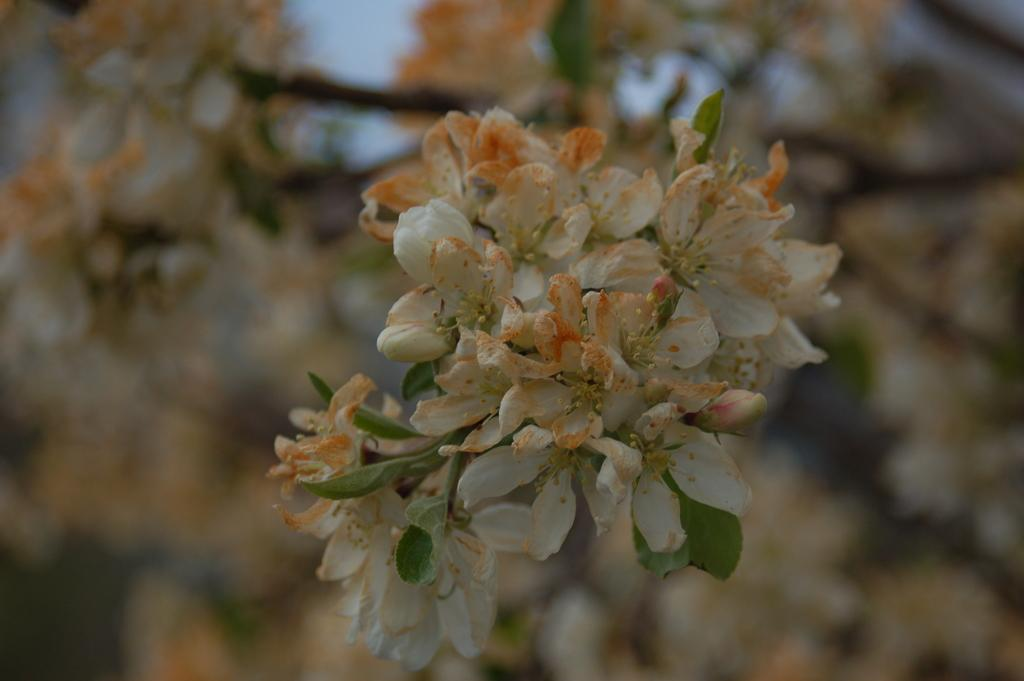What type of plant life is present in the image? There are flowers and leaves in the image. How is the background of the image depicted? The background of the image is blurred. What part of the natural environment can be seen in the image? The sky is visible in the background of the image. What is the weight of the wound on the flower in the image? There is no wound present on the flower in the image, and therefore no weight can be determined. 